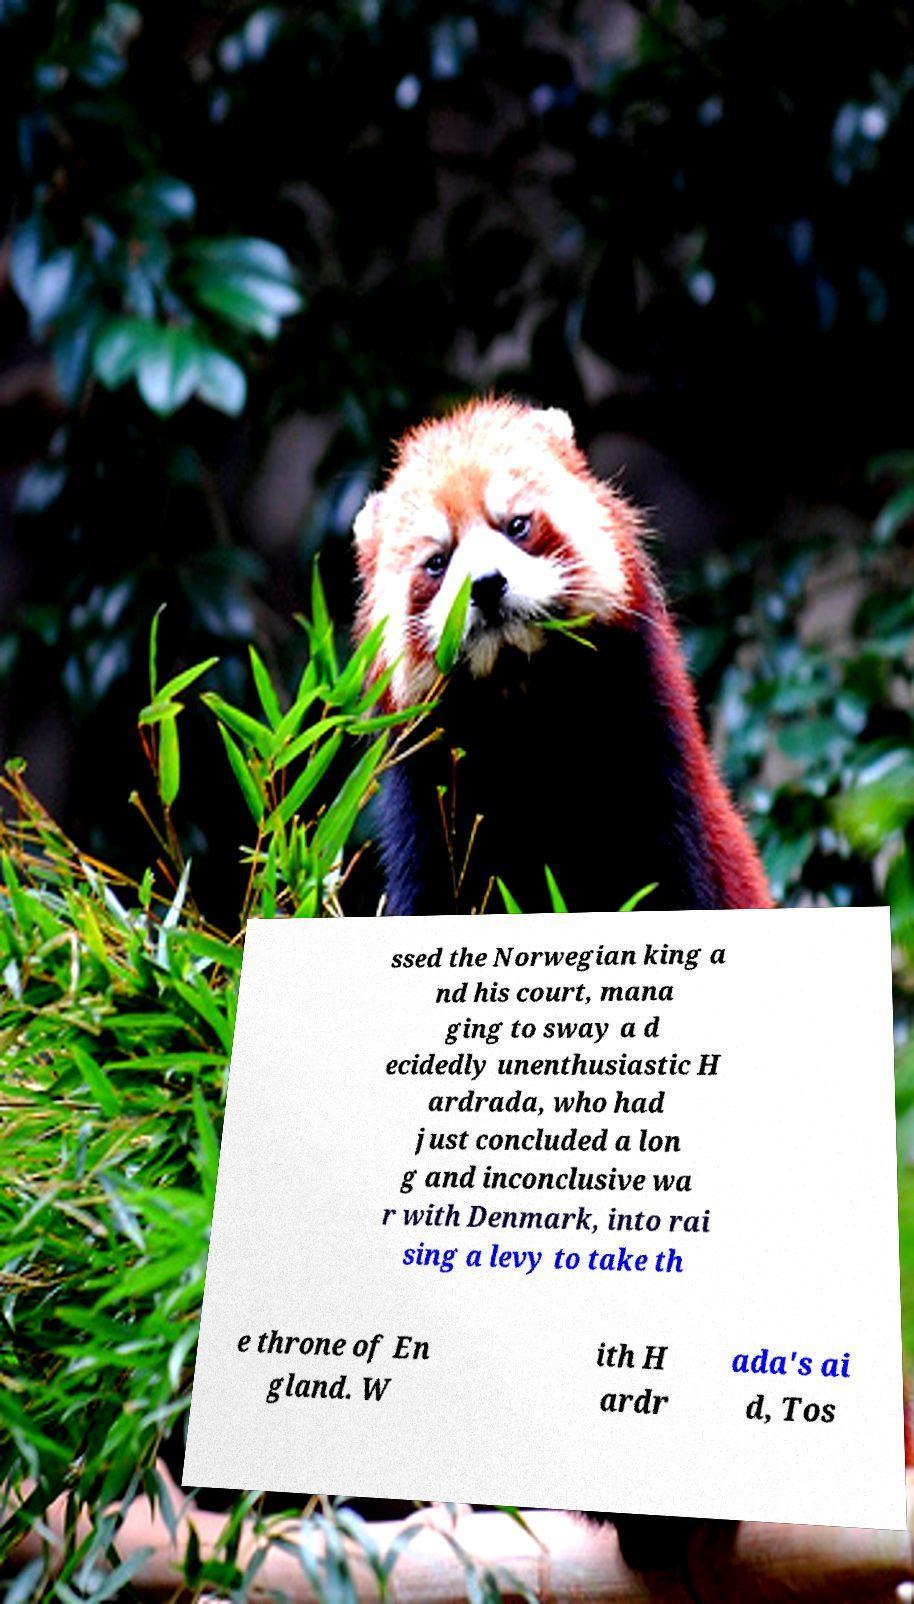Could you assist in decoding the text presented in this image and type it out clearly? ssed the Norwegian king a nd his court, mana ging to sway a d ecidedly unenthusiastic H ardrada, who had just concluded a lon g and inconclusive wa r with Denmark, into rai sing a levy to take th e throne of En gland. W ith H ardr ada's ai d, Tos 